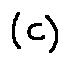Convert formula to latex. <formula><loc_0><loc_0><loc_500><loc_500>( C )</formula> 